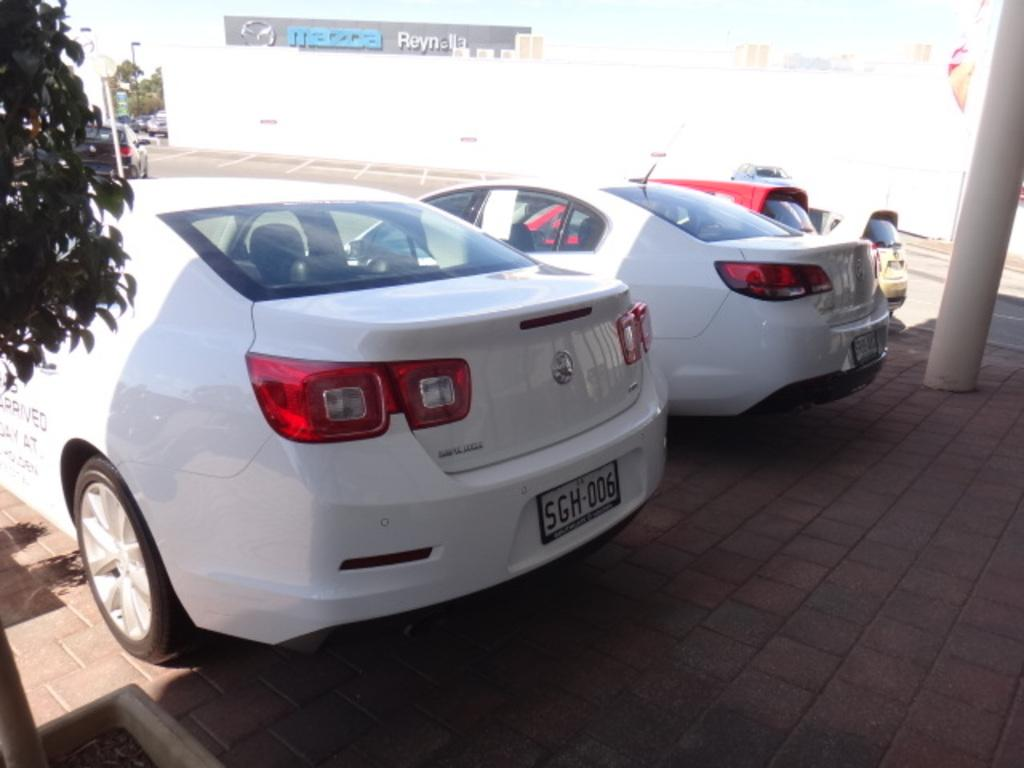<image>
Relay a brief, clear account of the picture shown. Several cars parked together at a Mazda dealership. 